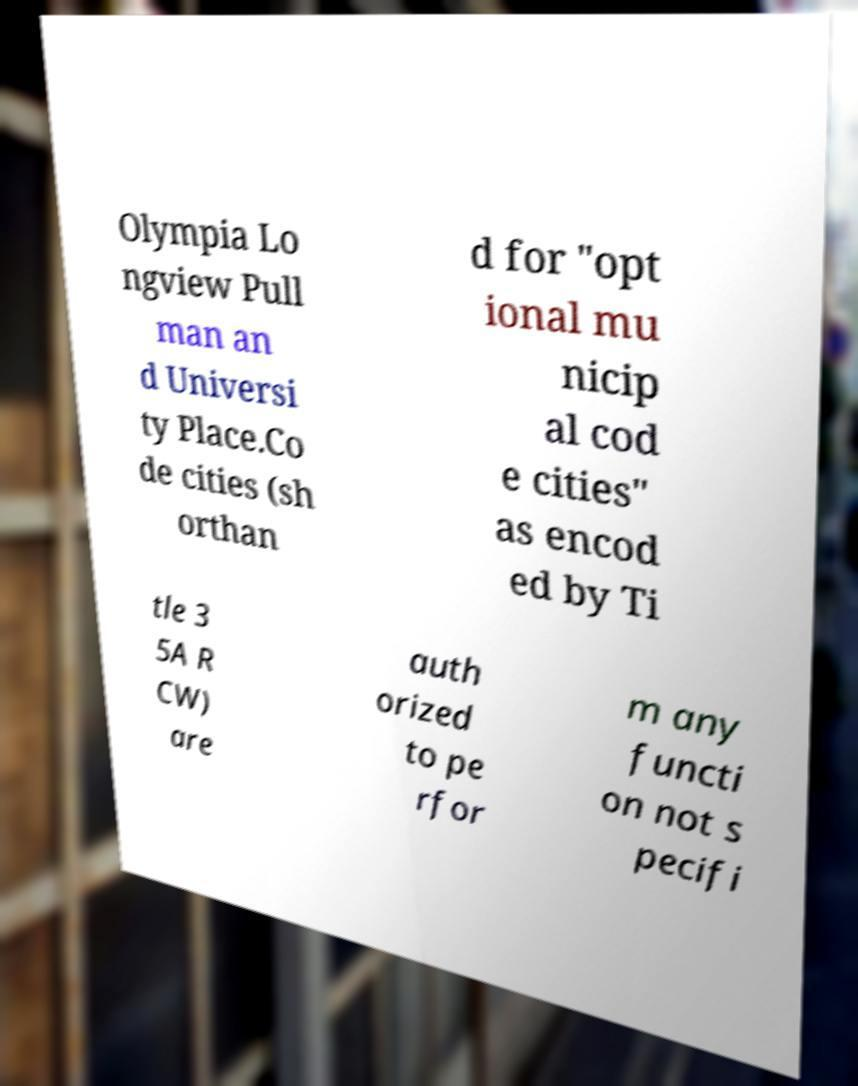Can you read and provide the text displayed in the image?This photo seems to have some interesting text. Can you extract and type it out for me? Olympia Lo ngview Pull man an d Universi ty Place.Co de cities (sh orthan d for "opt ional mu nicip al cod e cities" as encod ed by Ti tle 3 5A R CW) are auth orized to pe rfor m any functi on not s pecifi 